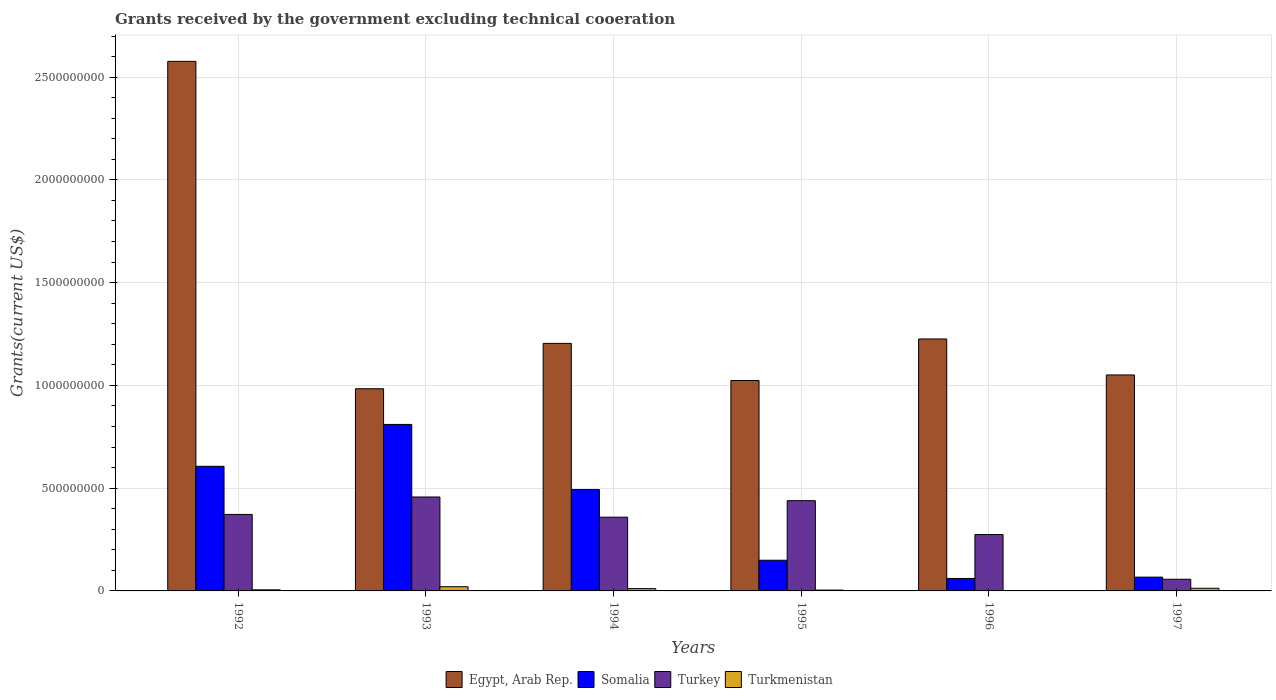How many groups of bars are there?
Provide a short and direct response. 6. How many bars are there on the 4th tick from the left?
Offer a very short reply. 4. What is the label of the 6th group of bars from the left?
Offer a terse response. 1997. In how many cases, is the number of bars for a given year not equal to the number of legend labels?
Offer a terse response. 0. What is the total grants received by the government in Turkey in 1996?
Give a very brief answer. 2.74e+08. Across all years, what is the maximum total grants received by the government in Egypt, Arab Rep.?
Give a very brief answer. 2.58e+09. Across all years, what is the minimum total grants received by the government in Turkey?
Your answer should be compact. 5.68e+07. In which year was the total grants received by the government in Egypt, Arab Rep. minimum?
Give a very brief answer. 1993. What is the total total grants received by the government in Turkmenistan in the graph?
Your answer should be very brief. 5.53e+07. What is the difference between the total grants received by the government in Egypt, Arab Rep. in 1994 and that in 1996?
Offer a very short reply. -2.15e+07. What is the difference between the total grants received by the government in Somalia in 1994 and the total grants received by the government in Turkmenistan in 1995?
Ensure brevity in your answer.  4.89e+08. What is the average total grants received by the government in Turkmenistan per year?
Make the answer very short. 9.22e+06. In the year 1994, what is the difference between the total grants received by the government in Egypt, Arab Rep. and total grants received by the government in Turkmenistan?
Make the answer very short. 1.19e+09. In how many years, is the total grants received by the government in Egypt, Arab Rep. greater than 1200000000 US$?
Your response must be concise. 3. What is the ratio of the total grants received by the government in Turkey in 1994 to that in 1996?
Make the answer very short. 1.31. Is the total grants received by the government in Egypt, Arab Rep. in 1993 less than that in 1994?
Make the answer very short. Yes. What is the difference between the highest and the second highest total grants received by the government in Turkmenistan?
Your response must be concise. 7.58e+06. What is the difference between the highest and the lowest total grants received by the government in Turkey?
Your answer should be compact. 4.00e+08. In how many years, is the total grants received by the government in Somalia greater than the average total grants received by the government in Somalia taken over all years?
Offer a very short reply. 3. Is the sum of the total grants received by the government in Somalia in 1995 and 1997 greater than the maximum total grants received by the government in Egypt, Arab Rep. across all years?
Provide a short and direct response. No. What does the 3rd bar from the left in 1993 represents?
Offer a terse response. Turkey. What does the 2nd bar from the right in 1997 represents?
Offer a terse response. Turkey. Is it the case that in every year, the sum of the total grants received by the government in Somalia and total grants received by the government in Turkey is greater than the total grants received by the government in Egypt, Arab Rep.?
Your response must be concise. No. What is the difference between two consecutive major ticks on the Y-axis?
Your answer should be compact. 5.00e+08. Are the values on the major ticks of Y-axis written in scientific E-notation?
Provide a short and direct response. No. What is the title of the graph?
Provide a succinct answer. Grants received by the government excluding technical cooeration. Does "Kiribati" appear as one of the legend labels in the graph?
Your answer should be very brief. No. What is the label or title of the X-axis?
Your answer should be very brief. Years. What is the label or title of the Y-axis?
Keep it short and to the point. Grants(current US$). What is the Grants(current US$) of Egypt, Arab Rep. in 1992?
Make the answer very short. 2.58e+09. What is the Grants(current US$) in Somalia in 1992?
Give a very brief answer. 6.06e+08. What is the Grants(current US$) in Turkey in 1992?
Provide a short and direct response. 3.72e+08. What is the Grants(current US$) in Turkmenistan in 1992?
Offer a terse response. 5.28e+06. What is the Grants(current US$) of Egypt, Arab Rep. in 1993?
Make the answer very short. 9.84e+08. What is the Grants(current US$) of Somalia in 1993?
Provide a succinct answer. 8.10e+08. What is the Grants(current US$) of Turkey in 1993?
Offer a very short reply. 4.57e+08. What is the Grants(current US$) of Turkmenistan in 1993?
Offer a terse response. 2.05e+07. What is the Grants(current US$) in Egypt, Arab Rep. in 1994?
Make the answer very short. 1.20e+09. What is the Grants(current US$) in Somalia in 1994?
Give a very brief answer. 4.93e+08. What is the Grants(current US$) in Turkey in 1994?
Your response must be concise. 3.59e+08. What is the Grants(current US$) of Turkmenistan in 1994?
Ensure brevity in your answer.  1.12e+07. What is the Grants(current US$) in Egypt, Arab Rep. in 1995?
Your answer should be very brief. 1.02e+09. What is the Grants(current US$) of Somalia in 1995?
Offer a very short reply. 1.49e+08. What is the Grants(current US$) of Turkey in 1995?
Your answer should be very brief. 4.39e+08. What is the Grants(current US$) of Turkmenistan in 1995?
Provide a short and direct response. 4.05e+06. What is the Grants(current US$) of Egypt, Arab Rep. in 1996?
Keep it short and to the point. 1.23e+09. What is the Grants(current US$) in Somalia in 1996?
Provide a short and direct response. 6.06e+07. What is the Grants(current US$) of Turkey in 1996?
Your response must be concise. 2.74e+08. What is the Grants(current US$) of Turkmenistan in 1996?
Provide a short and direct response. 1.32e+06. What is the Grants(current US$) of Egypt, Arab Rep. in 1997?
Ensure brevity in your answer.  1.05e+09. What is the Grants(current US$) in Somalia in 1997?
Give a very brief answer. 6.71e+07. What is the Grants(current US$) of Turkey in 1997?
Give a very brief answer. 5.68e+07. What is the Grants(current US$) of Turkmenistan in 1997?
Give a very brief answer. 1.29e+07. Across all years, what is the maximum Grants(current US$) of Egypt, Arab Rep.?
Offer a terse response. 2.58e+09. Across all years, what is the maximum Grants(current US$) of Somalia?
Provide a succinct answer. 8.10e+08. Across all years, what is the maximum Grants(current US$) of Turkey?
Give a very brief answer. 4.57e+08. Across all years, what is the maximum Grants(current US$) of Turkmenistan?
Make the answer very short. 2.05e+07. Across all years, what is the minimum Grants(current US$) of Egypt, Arab Rep.?
Your answer should be very brief. 9.84e+08. Across all years, what is the minimum Grants(current US$) in Somalia?
Offer a terse response. 6.06e+07. Across all years, what is the minimum Grants(current US$) in Turkey?
Offer a very short reply. 5.68e+07. Across all years, what is the minimum Grants(current US$) of Turkmenistan?
Your answer should be very brief. 1.32e+06. What is the total Grants(current US$) of Egypt, Arab Rep. in the graph?
Keep it short and to the point. 8.07e+09. What is the total Grants(current US$) in Somalia in the graph?
Keep it short and to the point. 2.19e+09. What is the total Grants(current US$) of Turkey in the graph?
Make the answer very short. 1.96e+09. What is the total Grants(current US$) of Turkmenistan in the graph?
Offer a terse response. 5.53e+07. What is the difference between the Grants(current US$) of Egypt, Arab Rep. in 1992 and that in 1993?
Provide a succinct answer. 1.59e+09. What is the difference between the Grants(current US$) in Somalia in 1992 and that in 1993?
Offer a terse response. -2.04e+08. What is the difference between the Grants(current US$) of Turkey in 1992 and that in 1993?
Give a very brief answer. -8.50e+07. What is the difference between the Grants(current US$) of Turkmenistan in 1992 and that in 1993?
Keep it short and to the point. -1.52e+07. What is the difference between the Grants(current US$) of Egypt, Arab Rep. in 1992 and that in 1994?
Provide a short and direct response. 1.37e+09. What is the difference between the Grants(current US$) in Somalia in 1992 and that in 1994?
Offer a very short reply. 1.13e+08. What is the difference between the Grants(current US$) of Turkey in 1992 and that in 1994?
Keep it short and to the point. 1.33e+07. What is the difference between the Grants(current US$) in Turkmenistan in 1992 and that in 1994?
Your answer should be very brief. -5.91e+06. What is the difference between the Grants(current US$) in Egypt, Arab Rep. in 1992 and that in 1995?
Ensure brevity in your answer.  1.55e+09. What is the difference between the Grants(current US$) in Somalia in 1992 and that in 1995?
Your response must be concise. 4.57e+08. What is the difference between the Grants(current US$) of Turkey in 1992 and that in 1995?
Your response must be concise. -6.70e+07. What is the difference between the Grants(current US$) in Turkmenistan in 1992 and that in 1995?
Your response must be concise. 1.23e+06. What is the difference between the Grants(current US$) of Egypt, Arab Rep. in 1992 and that in 1996?
Your answer should be very brief. 1.35e+09. What is the difference between the Grants(current US$) in Somalia in 1992 and that in 1996?
Provide a succinct answer. 5.46e+08. What is the difference between the Grants(current US$) of Turkey in 1992 and that in 1996?
Offer a very short reply. 9.78e+07. What is the difference between the Grants(current US$) in Turkmenistan in 1992 and that in 1996?
Your answer should be compact. 3.96e+06. What is the difference between the Grants(current US$) of Egypt, Arab Rep. in 1992 and that in 1997?
Make the answer very short. 1.53e+09. What is the difference between the Grants(current US$) of Somalia in 1992 and that in 1997?
Keep it short and to the point. 5.39e+08. What is the difference between the Grants(current US$) of Turkey in 1992 and that in 1997?
Keep it short and to the point. 3.15e+08. What is the difference between the Grants(current US$) of Turkmenistan in 1992 and that in 1997?
Provide a short and direct response. -7.66e+06. What is the difference between the Grants(current US$) of Egypt, Arab Rep. in 1993 and that in 1994?
Your answer should be very brief. -2.21e+08. What is the difference between the Grants(current US$) in Somalia in 1993 and that in 1994?
Your answer should be very brief. 3.17e+08. What is the difference between the Grants(current US$) of Turkey in 1993 and that in 1994?
Make the answer very short. 9.83e+07. What is the difference between the Grants(current US$) of Turkmenistan in 1993 and that in 1994?
Offer a terse response. 9.33e+06. What is the difference between the Grants(current US$) of Egypt, Arab Rep. in 1993 and that in 1995?
Make the answer very short. -4.01e+07. What is the difference between the Grants(current US$) in Somalia in 1993 and that in 1995?
Provide a short and direct response. 6.61e+08. What is the difference between the Grants(current US$) in Turkey in 1993 and that in 1995?
Your response must be concise. 1.80e+07. What is the difference between the Grants(current US$) of Turkmenistan in 1993 and that in 1995?
Your answer should be compact. 1.65e+07. What is the difference between the Grants(current US$) of Egypt, Arab Rep. in 1993 and that in 1996?
Provide a succinct answer. -2.42e+08. What is the difference between the Grants(current US$) of Somalia in 1993 and that in 1996?
Offer a very short reply. 7.49e+08. What is the difference between the Grants(current US$) in Turkey in 1993 and that in 1996?
Your answer should be compact. 1.83e+08. What is the difference between the Grants(current US$) of Turkmenistan in 1993 and that in 1996?
Your response must be concise. 1.92e+07. What is the difference between the Grants(current US$) in Egypt, Arab Rep. in 1993 and that in 1997?
Offer a very short reply. -6.72e+07. What is the difference between the Grants(current US$) of Somalia in 1993 and that in 1997?
Provide a succinct answer. 7.43e+08. What is the difference between the Grants(current US$) in Turkey in 1993 and that in 1997?
Give a very brief answer. 4.00e+08. What is the difference between the Grants(current US$) in Turkmenistan in 1993 and that in 1997?
Your response must be concise. 7.58e+06. What is the difference between the Grants(current US$) of Egypt, Arab Rep. in 1994 and that in 1995?
Offer a terse response. 1.81e+08. What is the difference between the Grants(current US$) of Somalia in 1994 and that in 1995?
Your answer should be compact. 3.44e+08. What is the difference between the Grants(current US$) in Turkey in 1994 and that in 1995?
Ensure brevity in your answer.  -8.02e+07. What is the difference between the Grants(current US$) of Turkmenistan in 1994 and that in 1995?
Ensure brevity in your answer.  7.14e+06. What is the difference between the Grants(current US$) in Egypt, Arab Rep. in 1994 and that in 1996?
Ensure brevity in your answer.  -2.15e+07. What is the difference between the Grants(current US$) of Somalia in 1994 and that in 1996?
Give a very brief answer. 4.32e+08. What is the difference between the Grants(current US$) in Turkey in 1994 and that in 1996?
Offer a very short reply. 8.45e+07. What is the difference between the Grants(current US$) of Turkmenistan in 1994 and that in 1996?
Provide a succinct answer. 9.87e+06. What is the difference between the Grants(current US$) in Egypt, Arab Rep. in 1994 and that in 1997?
Ensure brevity in your answer.  1.54e+08. What is the difference between the Grants(current US$) of Somalia in 1994 and that in 1997?
Your answer should be compact. 4.26e+08. What is the difference between the Grants(current US$) in Turkey in 1994 and that in 1997?
Make the answer very short. 3.02e+08. What is the difference between the Grants(current US$) in Turkmenistan in 1994 and that in 1997?
Make the answer very short. -1.75e+06. What is the difference between the Grants(current US$) in Egypt, Arab Rep. in 1995 and that in 1996?
Offer a very short reply. -2.02e+08. What is the difference between the Grants(current US$) of Somalia in 1995 and that in 1996?
Provide a short and direct response. 8.87e+07. What is the difference between the Grants(current US$) of Turkey in 1995 and that in 1996?
Your answer should be very brief. 1.65e+08. What is the difference between the Grants(current US$) of Turkmenistan in 1995 and that in 1996?
Keep it short and to the point. 2.73e+06. What is the difference between the Grants(current US$) in Egypt, Arab Rep. in 1995 and that in 1997?
Your answer should be very brief. -2.70e+07. What is the difference between the Grants(current US$) in Somalia in 1995 and that in 1997?
Your response must be concise. 8.22e+07. What is the difference between the Grants(current US$) in Turkey in 1995 and that in 1997?
Your answer should be very brief. 3.82e+08. What is the difference between the Grants(current US$) of Turkmenistan in 1995 and that in 1997?
Offer a very short reply. -8.89e+06. What is the difference between the Grants(current US$) of Egypt, Arab Rep. in 1996 and that in 1997?
Keep it short and to the point. 1.75e+08. What is the difference between the Grants(current US$) in Somalia in 1996 and that in 1997?
Your answer should be very brief. -6.48e+06. What is the difference between the Grants(current US$) in Turkey in 1996 and that in 1997?
Your answer should be compact. 2.18e+08. What is the difference between the Grants(current US$) in Turkmenistan in 1996 and that in 1997?
Provide a short and direct response. -1.16e+07. What is the difference between the Grants(current US$) of Egypt, Arab Rep. in 1992 and the Grants(current US$) of Somalia in 1993?
Your response must be concise. 1.77e+09. What is the difference between the Grants(current US$) in Egypt, Arab Rep. in 1992 and the Grants(current US$) in Turkey in 1993?
Your answer should be compact. 2.12e+09. What is the difference between the Grants(current US$) in Egypt, Arab Rep. in 1992 and the Grants(current US$) in Turkmenistan in 1993?
Offer a terse response. 2.56e+09. What is the difference between the Grants(current US$) in Somalia in 1992 and the Grants(current US$) in Turkey in 1993?
Keep it short and to the point. 1.49e+08. What is the difference between the Grants(current US$) in Somalia in 1992 and the Grants(current US$) in Turkmenistan in 1993?
Your answer should be compact. 5.86e+08. What is the difference between the Grants(current US$) of Turkey in 1992 and the Grants(current US$) of Turkmenistan in 1993?
Provide a short and direct response. 3.52e+08. What is the difference between the Grants(current US$) of Egypt, Arab Rep. in 1992 and the Grants(current US$) of Somalia in 1994?
Your answer should be compact. 2.08e+09. What is the difference between the Grants(current US$) of Egypt, Arab Rep. in 1992 and the Grants(current US$) of Turkey in 1994?
Make the answer very short. 2.22e+09. What is the difference between the Grants(current US$) in Egypt, Arab Rep. in 1992 and the Grants(current US$) in Turkmenistan in 1994?
Keep it short and to the point. 2.57e+09. What is the difference between the Grants(current US$) in Somalia in 1992 and the Grants(current US$) in Turkey in 1994?
Ensure brevity in your answer.  2.48e+08. What is the difference between the Grants(current US$) of Somalia in 1992 and the Grants(current US$) of Turkmenistan in 1994?
Keep it short and to the point. 5.95e+08. What is the difference between the Grants(current US$) in Turkey in 1992 and the Grants(current US$) in Turkmenistan in 1994?
Make the answer very short. 3.61e+08. What is the difference between the Grants(current US$) in Egypt, Arab Rep. in 1992 and the Grants(current US$) in Somalia in 1995?
Keep it short and to the point. 2.43e+09. What is the difference between the Grants(current US$) of Egypt, Arab Rep. in 1992 and the Grants(current US$) of Turkey in 1995?
Provide a short and direct response. 2.14e+09. What is the difference between the Grants(current US$) of Egypt, Arab Rep. in 1992 and the Grants(current US$) of Turkmenistan in 1995?
Make the answer very short. 2.57e+09. What is the difference between the Grants(current US$) in Somalia in 1992 and the Grants(current US$) in Turkey in 1995?
Give a very brief answer. 1.67e+08. What is the difference between the Grants(current US$) in Somalia in 1992 and the Grants(current US$) in Turkmenistan in 1995?
Your answer should be very brief. 6.02e+08. What is the difference between the Grants(current US$) of Turkey in 1992 and the Grants(current US$) of Turkmenistan in 1995?
Your answer should be very brief. 3.68e+08. What is the difference between the Grants(current US$) of Egypt, Arab Rep. in 1992 and the Grants(current US$) of Somalia in 1996?
Give a very brief answer. 2.52e+09. What is the difference between the Grants(current US$) of Egypt, Arab Rep. in 1992 and the Grants(current US$) of Turkey in 1996?
Provide a succinct answer. 2.30e+09. What is the difference between the Grants(current US$) in Egypt, Arab Rep. in 1992 and the Grants(current US$) in Turkmenistan in 1996?
Provide a succinct answer. 2.58e+09. What is the difference between the Grants(current US$) in Somalia in 1992 and the Grants(current US$) in Turkey in 1996?
Give a very brief answer. 3.32e+08. What is the difference between the Grants(current US$) in Somalia in 1992 and the Grants(current US$) in Turkmenistan in 1996?
Offer a terse response. 6.05e+08. What is the difference between the Grants(current US$) of Turkey in 1992 and the Grants(current US$) of Turkmenistan in 1996?
Your response must be concise. 3.71e+08. What is the difference between the Grants(current US$) of Egypt, Arab Rep. in 1992 and the Grants(current US$) of Somalia in 1997?
Your answer should be compact. 2.51e+09. What is the difference between the Grants(current US$) in Egypt, Arab Rep. in 1992 and the Grants(current US$) in Turkey in 1997?
Offer a very short reply. 2.52e+09. What is the difference between the Grants(current US$) in Egypt, Arab Rep. in 1992 and the Grants(current US$) in Turkmenistan in 1997?
Provide a short and direct response. 2.56e+09. What is the difference between the Grants(current US$) of Somalia in 1992 and the Grants(current US$) of Turkey in 1997?
Give a very brief answer. 5.50e+08. What is the difference between the Grants(current US$) of Somalia in 1992 and the Grants(current US$) of Turkmenistan in 1997?
Offer a very short reply. 5.93e+08. What is the difference between the Grants(current US$) of Turkey in 1992 and the Grants(current US$) of Turkmenistan in 1997?
Your response must be concise. 3.59e+08. What is the difference between the Grants(current US$) of Egypt, Arab Rep. in 1993 and the Grants(current US$) of Somalia in 1994?
Make the answer very short. 4.91e+08. What is the difference between the Grants(current US$) in Egypt, Arab Rep. in 1993 and the Grants(current US$) in Turkey in 1994?
Offer a very short reply. 6.25e+08. What is the difference between the Grants(current US$) of Egypt, Arab Rep. in 1993 and the Grants(current US$) of Turkmenistan in 1994?
Provide a short and direct response. 9.72e+08. What is the difference between the Grants(current US$) of Somalia in 1993 and the Grants(current US$) of Turkey in 1994?
Your response must be concise. 4.51e+08. What is the difference between the Grants(current US$) in Somalia in 1993 and the Grants(current US$) in Turkmenistan in 1994?
Your response must be concise. 7.99e+08. What is the difference between the Grants(current US$) in Turkey in 1993 and the Grants(current US$) in Turkmenistan in 1994?
Provide a succinct answer. 4.46e+08. What is the difference between the Grants(current US$) in Egypt, Arab Rep. in 1993 and the Grants(current US$) in Somalia in 1995?
Offer a very short reply. 8.34e+08. What is the difference between the Grants(current US$) of Egypt, Arab Rep. in 1993 and the Grants(current US$) of Turkey in 1995?
Make the answer very short. 5.45e+08. What is the difference between the Grants(current US$) in Egypt, Arab Rep. in 1993 and the Grants(current US$) in Turkmenistan in 1995?
Give a very brief answer. 9.80e+08. What is the difference between the Grants(current US$) of Somalia in 1993 and the Grants(current US$) of Turkey in 1995?
Make the answer very short. 3.71e+08. What is the difference between the Grants(current US$) of Somalia in 1993 and the Grants(current US$) of Turkmenistan in 1995?
Make the answer very short. 8.06e+08. What is the difference between the Grants(current US$) of Turkey in 1993 and the Grants(current US$) of Turkmenistan in 1995?
Your response must be concise. 4.53e+08. What is the difference between the Grants(current US$) in Egypt, Arab Rep. in 1993 and the Grants(current US$) in Somalia in 1996?
Offer a terse response. 9.23e+08. What is the difference between the Grants(current US$) of Egypt, Arab Rep. in 1993 and the Grants(current US$) of Turkey in 1996?
Give a very brief answer. 7.09e+08. What is the difference between the Grants(current US$) of Egypt, Arab Rep. in 1993 and the Grants(current US$) of Turkmenistan in 1996?
Provide a succinct answer. 9.82e+08. What is the difference between the Grants(current US$) of Somalia in 1993 and the Grants(current US$) of Turkey in 1996?
Your answer should be very brief. 5.36e+08. What is the difference between the Grants(current US$) of Somalia in 1993 and the Grants(current US$) of Turkmenistan in 1996?
Offer a terse response. 8.09e+08. What is the difference between the Grants(current US$) of Turkey in 1993 and the Grants(current US$) of Turkmenistan in 1996?
Your answer should be compact. 4.56e+08. What is the difference between the Grants(current US$) of Egypt, Arab Rep. in 1993 and the Grants(current US$) of Somalia in 1997?
Your answer should be very brief. 9.17e+08. What is the difference between the Grants(current US$) in Egypt, Arab Rep. in 1993 and the Grants(current US$) in Turkey in 1997?
Make the answer very short. 9.27e+08. What is the difference between the Grants(current US$) in Egypt, Arab Rep. in 1993 and the Grants(current US$) in Turkmenistan in 1997?
Your answer should be compact. 9.71e+08. What is the difference between the Grants(current US$) of Somalia in 1993 and the Grants(current US$) of Turkey in 1997?
Offer a terse response. 7.53e+08. What is the difference between the Grants(current US$) in Somalia in 1993 and the Grants(current US$) in Turkmenistan in 1997?
Ensure brevity in your answer.  7.97e+08. What is the difference between the Grants(current US$) of Turkey in 1993 and the Grants(current US$) of Turkmenistan in 1997?
Keep it short and to the point. 4.44e+08. What is the difference between the Grants(current US$) in Egypt, Arab Rep. in 1994 and the Grants(current US$) in Somalia in 1995?
Make the answer very short. 1.06e+09. What is the difference between the Grants(current US$) in Egypt, Arab Rep. in 1994 and the Grants(current US$) in Turkey in 1995?
Offer a terse response. 7.65e+08. What is the difference between the Grants(current US$) in Egypt, Arab Rep. in 1994 and the Grants(current US$) in Turkmenistan in 1995?
Provide a succinct answer. 1.20e+09. What is the difference between the Grants(current US$) in Somalia in 1994 and the Grants(current US$) in Turkey in 1995?
Ensure brevity in your answer.  5.40e+07. What is the difference between the Grants(current US$) in Somalia in 1994 and the Grants(current US$) in Turkmenistan in 1995?
Offer a terse response. 4.89e+08. What is the difference between the Grants(current US$) in Turkey in 1994 and the Grants(current US$) in Turkmenistan in 1995?
Give a very brief answer. 3.55e+08. What is the difference between the Grants(current US$) of Egypt, Arab Rep. in 1994 and the Grants(current US$) of Somalia in 1996?
Ensure brevity in your answer.  1.14e+09. What is the difference between the Grants(current US$) in Egypt, Arab Rep. in 1994 and the Grants(current US$) in Turkey in 1996?
Give a very brief answer. 9.30e+08. What is the difference between the Grants(current US$) in Egypt, Arab Rep. in 1994 and the Grants(current US$) in Turkmenistan in 1996?
Ensure brevity in your answer.  1.20e+09. What is the difference between the Grants(current US$) in Somalia in 1994 and the Grants(current US$) in Turkey in 1996?
Ensure brevity in your answer.  2.19e+08. What is the difference between the Grants(current US$) of Somalia in 1994 and the Grants(current US$) of Turkmenistan in 1996?
Offer a terse response. 4.92e+08. What is the difference between the Grants(current US$) in Turkey in 1994 and the Grants(current US$) in Turkmenistan in 1996?
Your answer should be very brief. 3.57e+08. What is the difference between the Grants(current US$) of Egypt, Arab Rep. in 1994 and the Grants(current US$) of Somalia in 1997?
Ensure brevity in your answer.  1.14e+09. What is the difference between the Grants(current US$) of Egypt, Arab Rep. in 1994 and the Grants(current US$) of Turkey in 1997?
Your response must be concise. 1.15e+09. What is the difference between the Grants(current US$) of Egypt, Arab Rep. in 1994 and the Grants(current US$) of Turkmenistan in 1997?
Keep it short and to the point. 1.19e+09. What is the difference between the Grants(current US$) of Somalia in 1994 and the Grants(current US$) of Turkey in 1997?
Make the answer very short. 4.36e+08. What is the difference between the Grants(current US$) in Somalia in 1994 and the Grants(current US$) in Turkmenistan in 1997?
Provide a succinct answer. 4.80e+08. What is the difference between the Grants(current US$) of Turkey in 1994 and the Grants(current US$) of Turkmenistan in 1997?
Make the answer very short. 3.46e+08. What is the difference between the Grants(current US$) in Egypt, Arab Rep. in 1995 and the Grants(current US$) in Somalia in 1996?
Provide a short and direct response. 9.63e+08. What is the difference between the Grants(current US$) of Egypt, Arab Rep. in 1995 and the Grants(current US$) of Turkey in 1996?
Offer a terse response. 7.49e+08. What is the difference between the Grants(current US$) in Egypt, Arab Rep. in 1995 and the Grants(current US$) in Turkmenistan in 1996?
Offer a terse response. 1.02e+09. What is the difference between the Grants(current US$) in Somalia in 1995 and the Grants(current US$) in Turkey in 1996?
Keep it short and to the point. -1.25e+08. What is the difference between the Grants(current US$) in Somalia in 1995 and the Grants(current US$) in Turkmenistan in 1996?
Provide a short and direct response. 1.48e+08. What is the difference between the Grants(current US$) in Turkey in 1995 and the Grants(current US$) in Turkmenistan in 1996?
Give a very brief answer. 4.38e+08. What is the difference between the Grants(current US$) of Egypt, Arab Rep. in 1995 and the Grants(current US$) of Somalia in 1997?
Your response must be concise. 9.57e+08. What is the difference between the Grants(current US$) of Egypt, Arab Rep. in 1995 and the Grants(current US$) of Turkey in 1997?
Your answer should be compact. 9.67e+08. What is the difference between the Grants(current US$) of Egypt, Arab Rep. in 1995 and the Grants(current US$) of Turkmenistan in 1997?
Your response must be concise. 1.01e+09. What is the difference between the Grants(current US$) of Somalia in 1995 and the Grants(current US$) of Turkey in 1997?
Your response must be concise. 9.26e+07. What is the difference between the Grants(current US$) of Somalia in 1995 and the Grants(current US$) of Turkmenistan in 1997?
Keep it short and to the point. 1.36e+08. What is the difference between the Grants(current US$) in Turkey in 1995 and the Grants(current US$) in Turkmenistan in 1997?
Your answer should be compact. 4.26e+08. What is the difference between the Grants(current US$) of Egypt, Arab Rep. in 1996 and the Grants(current US$) of Somalia in 1997?
Your answer should be very brief. 1.16e+09. What is the difference between the Grants(current US$) in Egypt, Arab Rep. in 1996 and the Grants(current US$) in Turkey in 1997?
Provide a short and direct response. 1.17e+09. What is the difference between the Grants(current US$) in Egypt, Arab Rep. in 1996 and the Grants(current US$) in Turkmenistan in 1997?
Offer a very short reply. 1.21e+09. What is the difference between the Grants(current US$) of Somalia in 1996 and the Grants(current US$) of Turkey in 1997?
Offer a terse response. 3.85e+06. What is the difference between the Grants(current US$) of Somalia in 1996 and the Grants(current US$) of Turkmenistan in 1997?
Offer a very short reply. 4.77e+07. What is the difference between the Grants(current US$) of Turkey in 1996 and the Grants(current US$) of Turkmenistan in 1997?
Your answer should be compact. 2.61e+08. What is the average Grants(current US$) of Egypt, Arab Rep. per year?
Ensure brevity in your answer.  1.34e+09. What is the average Grants(current US$) of Somalia per year?
Give a very brief answer. 3.64e+08. What is the average Grants(current US$) of Turkey per year?
Make the answer very short. 3.26e+08. What is the average Grants(current US$) in Turkmenistan per year?
Your response must be concise. 9.22e+06. In the year 1992, what is the difference between the Grants(current US$) in Egypt, Arab Rep. and Grants(current US$) in Somalia?
Your response must be concise. 1.97e+09. In the year 1992, what is the difference between the Grants(current US$) in Egypt, Arab Rep. and Grants(current US$) in Turkey?
Your answer should be very brief. 2.20e+09. In the year 1992, what is the difference between the Grants(current US$) in Egypt, Arab Rep. and Grants(current US$) in Turkmenistan?
Give a very brief answer. 2.57e+09. In the year 1992, what is the difference between the Grants(current US$) in Somalia and Grants(current US$) in Turkey?
Offer a terse response. 2.34e+08. In the year 1992, what is the difference between the Grants(current US$) in Somalia and Grants(current US$) in Turkmenistan?
Make the answer very short. 6.01e+08. In the year 1992, what is the difference between the Grants(current US$) of Turkey and Grants(current US$) of Turkmenistan?
Offer a very short reply. 3.67e+08. In the year 1993, what is the difference between the Grants(current US$) of Egypt, Arab Rep. and Grants(current US$) of Somalia?
Make the answer very short. 1.74e+08. In the year 1993, what is the difference between the Grants(current US$) in Egypt, Arab Rep. and Grants(current US$) in Turkey?
Offer a very short reply. 5.27e+08. In the year 1993, what is the difference between the Grants(current US$) of Egypt, Arab Rep. and Grants(current US$) of Turkmenistan?
Offer a terse response. 9.63e+08. In the year 1993, what is the difference between the Grants(current US$) of Somalia and Grants(current US$) of Turkey?
Offer a terse response. 3.53e+08. In the year 1993, what is the difference between the Grants(current US$) of Somalia and Grants(current US$) of Turkmenistan?
Your answer should be very brief. 7.90e+08. In the year 1993, what is the difference between the Grants(current US$) of Turkey and Grants(current US$) of Turkmenistan?
Your answer should be compact. 4.37e+08. In the year 1994, what is the difference between the Grants(current US$) of Egypt, Arab Rep. and Grants(current US$) of Somalia?
Keep it short and to the point. 7.11e+08. In the year 1994, what is the difference between the Grants(current US$) in Egypt, Arab Rep. and Grants(current US$) in Turkey?
Provide a succinct answer. 8.46e+08. In the year 1994, what is the difference between the Grants(current US$) of Egypt, Arab Rep. and Grants(current US$) of Turkmenistan?
Keep it short and to the point. 1.19e+09. In the year 1994, what is the difference between the Grants(current US$) in Somalia and Grants(current US$) in Turkey?
Keep it short and to the point. 1.34e+08. In the year 1994, what is the difference between the Grants(current US$) of Somalia and Grants(current US$) of Turkmenistan?
Provide a short and direct response. 4.82e+08. In the year 1994, what is the difference between the Grants(current US$) in Turkey and Grants(current US$) in Turkmenistan?
Your answer should be compact. 3.48e+08. In the year 1995, what is the difference between the Grants(current US$) of Egypt, Arab Rep. and Grants(current US$) of Somalia?
Offer a terse response. 8.74e+08. In the year 1995, what is the difference between the Grants(current US$) in Egypt, Arab Rep. and Grants(current US$) in Turkey?
Ensure brevity in your answer.  5.85e+08. In the year 1995, what is the difference between the Grants(current US$) in Egypt, Arab Rep. and Grants(current US$) in Turkmenistan?
Make the answer very short. 1.02e+09. In the year 1995, what is the difference between the Grants(current US$) of Somalia and Grants(current US$) of Turkey?
Provide a short and direct response. -2.90e+08. In the year 1995, what is the difference between the Grants(current US$) in Somalia and Grants(current US$) in Turkmenistan?
Give a very brief answer. 1.45e+08. In the year 1995, what is the difference between the Grants(current US$) of Turkey and Grants(current US$) of Turkmenistan?
Make the answer very short. 4.35e+08. In the year 1996, what is the difference between the Grants(current US$) of Egypt, Arab Rep. and Grants(current US$) of Somalia?
Your answer should be very brief. 1.17e+09. In the year 1996, what is the difference between the Grants(current US$) of Egypt, Arab Rep. and Grants(current US$) of Turkey?
Keep it short and to the point. 9.52e+08. In the year 1996, what is the difference between the Grants(current US$) of Egypt, Arab Rep. and Grants(current US$) of Turkmenistan?
Your answer should be very brief. 1.22e+09. In the year 1996, what is the difference between the Grants(current US$) of Somalia and Grants(current US$) of Turkey?
Keep it short and to the point. -2.14e+08. In the year 1996, what is the difference between the Grants(current US$) in Somalia and Grants(current US$) in Turkmenistan?
Provide a succinct answer. 5.93e+07. In the year 1996, what is the difference between the Grants(current US$) in Turkey and Grants(current US$) in Turkmenistan?
Your response must be concise. 2.73e+08. In the year 1997, what is the difference between the Grants(current US$) in Egypt, Arab Rep. and Grants(current US$) in Somalia?
Keep it short and to the point. 9.84e+08. In the year 1997, what is the difference between the Grants(current US$) in Egypt, Arab Rep. and Grants(current US$) in Turkey?
Your answer should be very brief. 9.94e+08. In the year 1997, what is the difference between the Grants(current US$) of Egypt, Arab Rep. and Grants(current US$) of Turkmenistan?
Ensure brevity in your answer.  1.04e+09. In the year 1997, what is the difference between the Grants(current US$) in Somalia and Grants(current US$) in Turkey?
Keep it short and to the point. 1.03e+07. In the year 1997, what is the difference between the Grants(current US$) in Somalia and Grants(current US$) in Turkmenistan?
Offer a terse response. 5.42e+07. In the year 1997, what is the difference between the Grants(current US$) of Turkey and Grants(current US$) of Turkmenistan?
Your response must be concise. 4.38e+07. What is the ratio of the Grants(current US$) of Egypt, Arab Rep. in 1992 to that in 1993?
Offer a very short reply. 2.62. What is the ratio of the Grants(current US$) of Somalia in 1992 to that in 1993?
Your answer should be compact. 0.75. What is the ratio of the Grants(current US$) of Turkey in 1992 to that in 1993?
Your answer should be compact. 0.81. What is the ratio of the Grants(current US$) of Turkmenistan in 1992 to that in 1993?
Your response must be concise. 0.26. What is the ratio of the Grants(current US$) of Egypt, Arab Rep. in 1992 to that in 1994?
Make the answer very short. 2.14. What is the ratio of the Grants(current US$) of Somalia in 1992 to that in 1994?
Give a very brief answer. 1.23. What is the ratio of the Grants(current US$) in Turkmenistan in 1992 to that in 1994?
Your answer should be very brief. 0.47. What is the ratio of the Grants(current US$) of Egypt, Arab Rep. in 1992 to that in 1995?
Offer a very short reply. 2.52. What is the ratio of the Grants(current US$) in Somalia in 1992 to that in 1995?
Provide a succinct answer. 4.06. What is the ratio of the Grants(current US$) of Turkey in 1992 to that in 1995?
Your answer should be compact. 0.85. What is the ratio of the Grants(current US$) in Turkmenistan in 1992 to that in 1995?
Ensure brevity in your answer.  1.3. What is the ratio of the Grants(current US$) of Egypt, Arab Rep. in 1992 to that in 1996?
Your response must be concise. 2.1. What is the ratio of the Grants(current US$) of Somalia in 1992 to that in 1996?
Give a very brief answer. 10. What is the ratio of the Grants(current US$) in Turkey in 1992 to that in 1996?
Ensure brevity in your answer.  1.36. What is the ratio of the Grants(current US$) in Egypt, Arab Rep. in 1992 to that in 1997?
Offer a very short reply. 2.45. What is the ratio of the Grants(current US$) in Somalia in 1992 to that in 1997?
Provide a short and direct response. 9.03. What is the ratio of the Grants(current US$) in Turkey in 1992 to that in 1997?
Provide a short and direct response. 6.55. What is the ratio of the Grants(current US$) in Turkmenistan in 1992 to that in 1997?
Make the answer very short. 0.41. What is the ratio of the Grants(current US$) in Egypt, Arab Rep. in 1993 to that in 1994?
Your answer should be very brief. 0.82. What is the ratio of the Grants(current US$) in Somalia in 1993 to that in 1994?
Offer a very short reply. 1.64. What is the ratio of the Grants(current US$) in Turkey in 1993 to that in 1994?
Offer a very short reply. 1.27. What is the ratio of the Grants(current US$) of Turkmenistan in 1993 to that in 1994?
Offer a terse response. 1.83. What is the ratio of the Grants(current US$) of Egypt, Arab Rep. in 1993 to that in 1995?
Provide a short and direct response. 0.96. What is the ratio of the Grants(current US$) in Somalia in 1993 to that in 1995?
Your answer should be very brief. 5.42. What is the ratio of the Grants(current US$) of Turkey in 1993 to that in 1995?
Offer a very short reply. 1.04. What is the ratio of the Grants(current US$) of Turkmenistan in 1993 to that in 1995?
Offer a very short reply. 5.07. What is the ratio of the Grants(current US$) in Egypt, Arab Rep. in 1993 to that in 1996?
Provide a short and direct response. 0.8. What is the ratio of the Grants(current US$) in Somalia in 1993 to that in 1996?
Make the answer very short. 13.36. What is the ratio of the Grants(current US$) in Turkey in 1993 to that in 1996?
Your answer should be very brief. 1.67. What is the ratio of the Grants(current US$) of Turkmenistan in 1993 to that in 1996?
Provide a succinct answer. 15.55. What is the ratio of the Grants(current US$) in Egypt, Arab Rep. in 1993 to that in 1997?
Your answer should be compact. 0.94. What is the ratio of the Grants(current US$) of Somalia in 1993 to that in 1997?
Give a very brief answer. 12.07. What is the ratio of the Grants(current US$) of Turkey in 1993 to that in 1997?
Keep it short and to the point. 8.05. What is the ratio of the Grants(current US$) of Turkmenistan in 1993 to that in 1997?
Offer a very short reply. 1.59. What is the ratio of the Grants(current US$) in Egypt, Arab Rep. in 1994 to that in 1995?
Provide a succinct answer. 1.18. What is the ratio of the Grants(current US$) of Somalia in 1994 to that in 1995?
Ensure brevity in your answer.  3.3. What is the ratio of the Grants(current US$) in Turkey in 1994 to that in 1995?
Your answer should be very brief. 0.82. What is the ratio of the Grants(current US$) of Turkmenistan in 1994 to that in 1995?
Give a very brief answer. 2.76. What is the ratio of the Grants(current US$) of Egypt, Arab Rep. in 1994 to that in 1996?
Offer a terse response. 0.98. What is the ratio of the Grants(current US$) of Somalia in 1994 to that in 1996?
Give a very brief answer. 8.13. What is the ratio of the Grants(current US$) in Turkey in 1994 to that in 1996?
Your answer should be compact. 1.31. What is the ratio of the Grants(current US$) of Turkmenistan in 1994 to that in 1996?
Keep it short and to the point. 8.48. What is the ratio of the Grants(current US$) of Egypt, Arab Rep. in 1994 to that in 1997?
Ensure brevity in your answer.  1.15. What is the ratio of the Grants(current US$) in Somalia in 1994 to that in 1997?
Provide a succinct answer. 7.35. What is the ratio of the Grants(current US$) in Turkey in 1994 to that in 1997?
Give a very brief answer. 6.32. What is the ratio of the Grants(current US$) of Turkmenistan in 1994 to that in 1997?
Provide a succinct answer. 0.86. What is the ratio of the Grants(current US$) in Egypt, Arab Rep. in 1995 to that in 1996?
Offer a very short reply. 0.84. What is the ratio of the Grants(current US$) of Somalia in 1995 to that in 1996?
Offer a very short reply. 2.46. What is the ratio of the Grants(current US$) in Turkey in 1995 to that in 1996?
Your response must be concise. 1.6. What is the ratio of the Grants(current US$) in Turkmenistan in 1995 to that in 1996?
Provide a succinct answer. 3.07. What is the ratio of the Grants(current US$) of Egypt, Arab Rep. in 1995 to that in 1997?
Offer a very short reply. 0.97. What is the ratio of the Grants(current US$) of Somalia in 1995 to that in 1997?
Provide a succinct answer. 2.23. What is the ratio of the Grants(current US$) of Turkey in 1995 to that in 1997?
Make the answer very short. 7.73. What is the ratio of the Grants(current US$) of Turkmenistan in 1995 to that in 1997?
Make the answer very short. 0.31. What is the ratio of the Grants(current US$) in Egypt, Arab Rep. in 1996 to that in 1997?
Your answer should be compact. 1.17. What is the ratio of the Grants(current US$) of Somalia in 1996 to that in 1997?
Offer a very short reply. 0.9. What is the ratio of the Grants(current US$) of Turkey in 1996 to that in 1997?
Your answer should be very brief. 4.83. What is the ratio of the Grants(current US$) of Turkmenistan in 1996 to that in 1997?
Provide a short and direct response. 0.1. What is the difference between the highest and the second highest Grants(current US$) in Egypt, Arab Rep.?
Provide a short and direct response. 1.35e+09. What is the difference between the highest and the second highest Grants(current US$) in Somalia?
Your response must be concise. 2.04e+08. What is the difference between the highest and the second highest Grants(current US$) in Turkey?
Your response must be concise. 1.80e+07. What is the difference between the highest and the second highest Grants(current US$) of Turkmenistan?
Give a very brief answer. 7.58e+06. What is the difference between the highest and the lowest Grants(current US$) in Egypt, Arab Rep.?
Offer a very short reply. 1.59e+09. What is the difference between the highest and the lowest Grants(current US$) of Somalia?
Give a very brief answer. 7.49e+08. What is the difference between the highest and the lowest Grants(current US$) in Turkey?
Keep it short and to the point. 4.00e+08. What is the difference between the highest and the lowest Grants(current US$) of Turkmenistan?
Your answer should be very brief. 1.92e+07. 